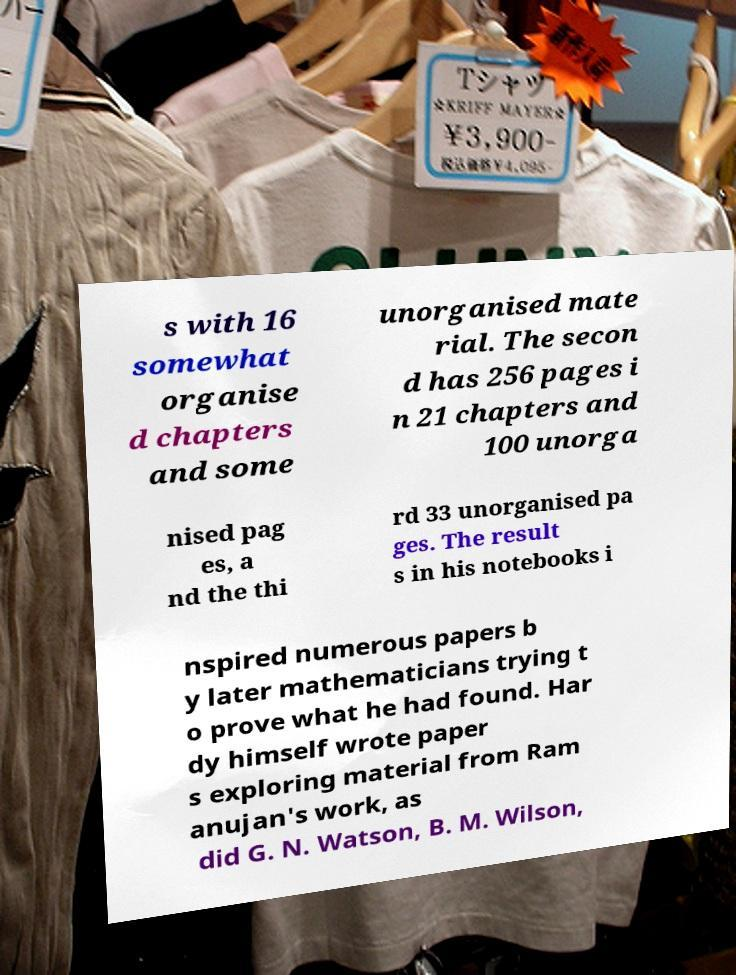Could you extract and type out the text from this image? s with 16 somewhat organise d chapters and some unorganised mate rial. The secon d has 256 pages i n 21 chapters and 100 unorga nised pag es, a nd the thi rd 33 unorganised pa ges. The result s in his notebooks i nspired numerous papers b y later mathematicians trying t o prove what he had found. Har dy himself wrote paper s exploring material from Ram anujan's work, as did G. N. Watson, B. M. Wilson, 